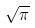Convert formula to latex. <formula><loc_0><loc_0><loc_500><loc_500>\sqrt { \pi }</formula> 